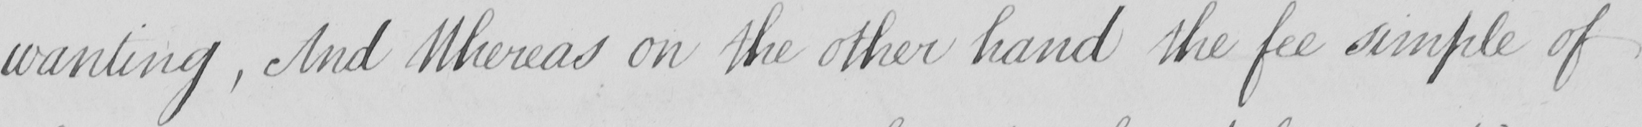Please transcribe the handwritten text in this image. wanting  , And Whereas on the other hand the fee simple of 